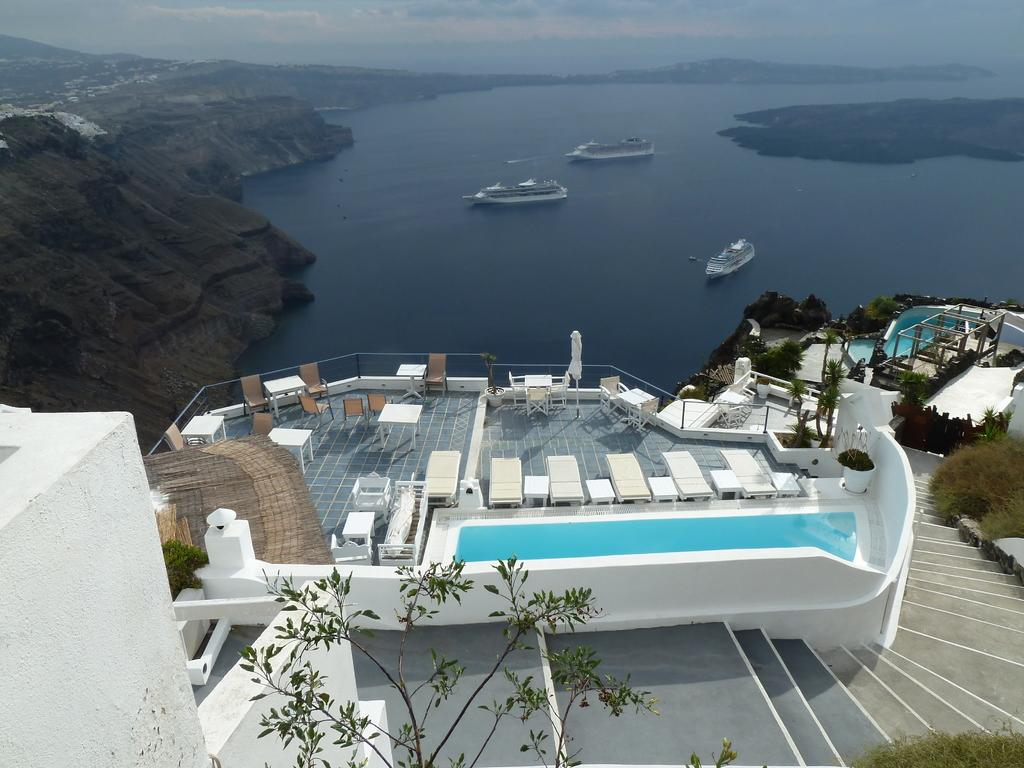What type of furniture is present in the image? There are tables and chairs in the image. What type of natural elements can be seen in the image? There are trees in the image. What type of man-made structures are visible in the image? There are buildings in the image. What architectural feature is present in the image? There are stairs in the image. What can be seen in the background of the image? There is water visible in the background of the image, and boats are present in the water. What is the purpose of the beginner in the image? There is no reference to a beginner in the image, so it is not possible to determine their purpose. What is the size of the size in the image? There is no object named "size" present in the image, so it is not possible to determine its size. 